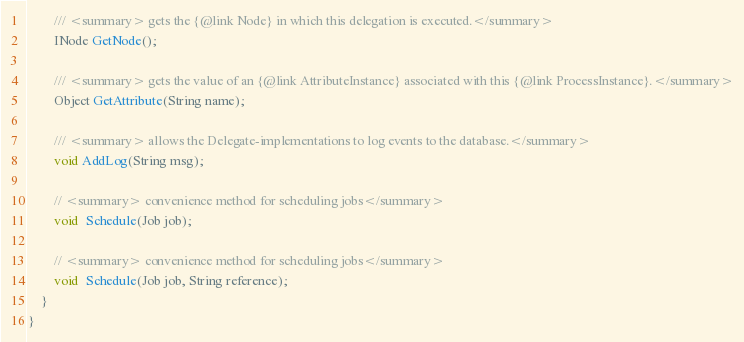<code> <loc_0><loc_0><loc_500><loc_500><_C#_>
		/// <summary> gets the {@link Node} in which this delegation is executed.</summary>
		INode GetNode();

		/// <summary> gets the value of an {@link AttributeInstance} associated with this {@link ProcessInstance}.</summary>
		Object GetAttribute(String name);

		/// <summary> allows the Delegate-implementations to log events to the database.</summary>
		void AddLog(String msg);

		// <summary> convenience method for scheduling jobs</summary>
		void  Schedule(Job job);

		// <summary> convenience method for scheduling jobs</summary>
		void  Schedule(Job job, String reference);
	}
}</code> 